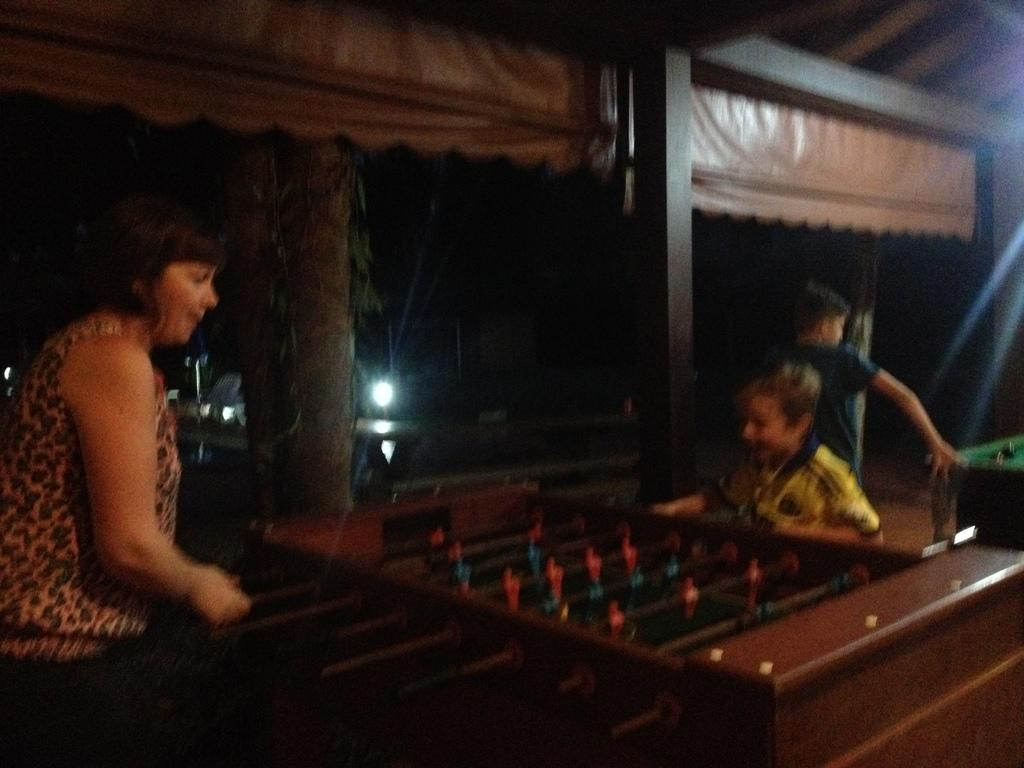Who is present in the image? There is a woman in the image. What activity is the child engaged in? A child is playing football in the image. What object is associated with the football game? There is a table associated with the football game. What natural element can be seen in the image? There is a bark of a tree in the image. What can be seen in the background of the image? There is a light in the background of the image. How many ducks are sitting on the table during the football game? There are no ducks present in the image, and therefore no ducks are sitting on the table during the football game. 